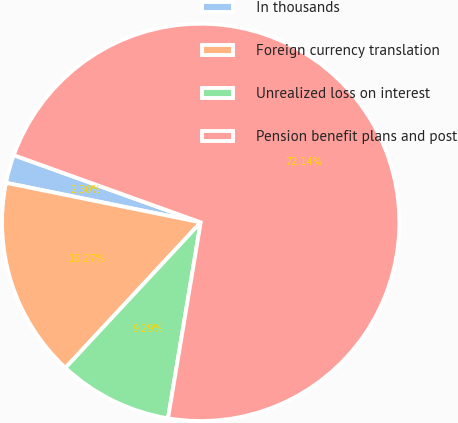Convert chart to OTSL. <chart><loc_0><loc_0><loc_500><loc_500><pie_chart><fcel>In thousands<fcel>Foreign currency translation<fcel>Unrealized loss on interest<fcel>Pension benefit plans and post<nl><fcel>2.3%<fcel>16.27%<fcel>9.29%<fcel>72.14%<nl></chart> 